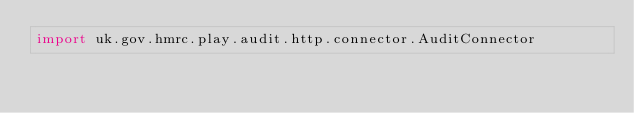Convert code to text. <code><loc_0><loc_0><loc_500><loc_500><_Scala_>import uk.gov.hmrc.play.audit.http.connector.AuditConnector</code> 